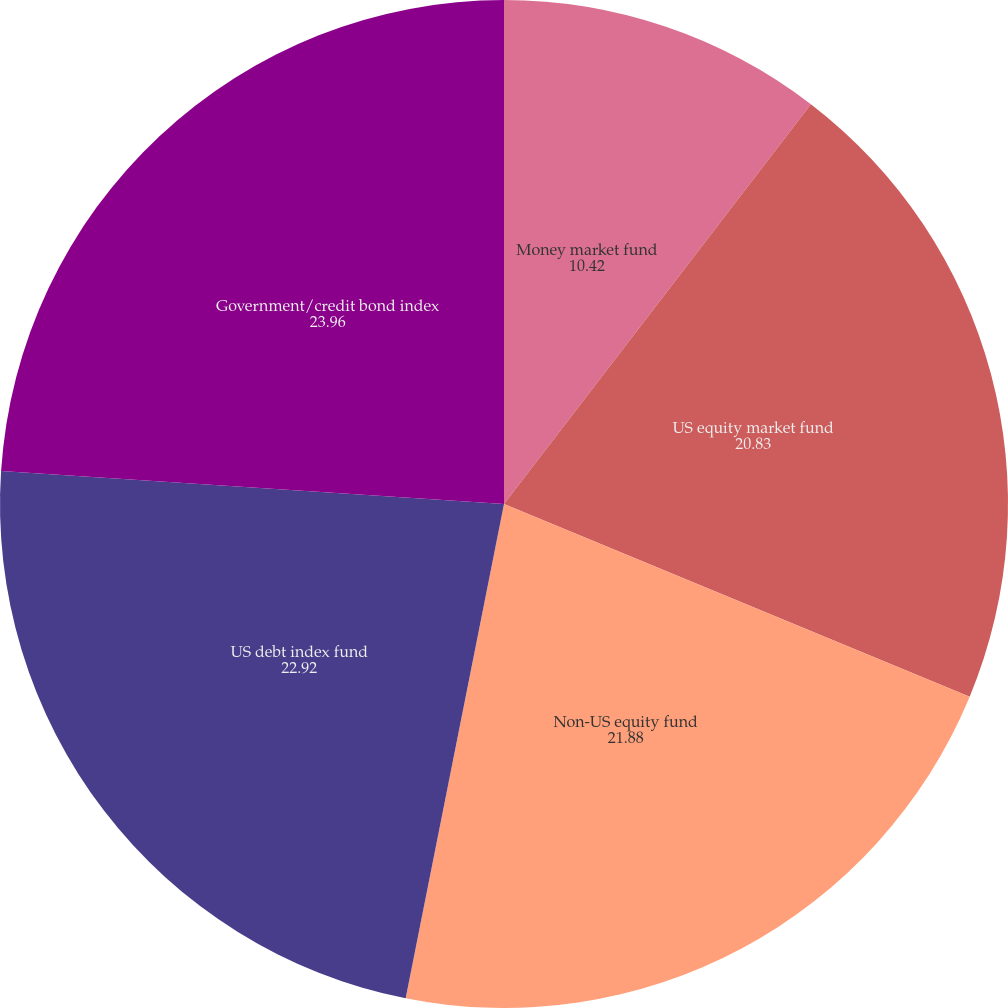<chart> <loc_0><loc_0><loc_500><loc_500><pie_chart><fcel>Money market fund<fcel>US equity market fund<fcel>Non-US equity fund<fcel>US debt index fund<fcel>Government/credit bond index<nl><fcel>10.42%<fcel>20.83%<fcel>21.88%<fcel>22.92%<fcel>23.96%<nl></chart> 